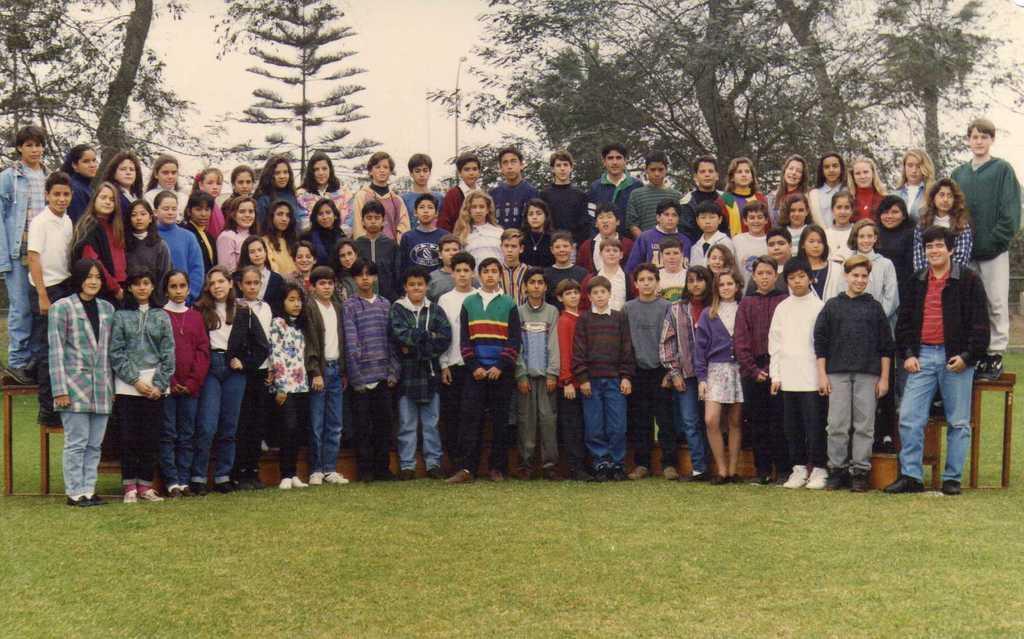Can you describe this image briefly? In this image there are group of children standing on three steps on a grass, behind them there are so many trees. 